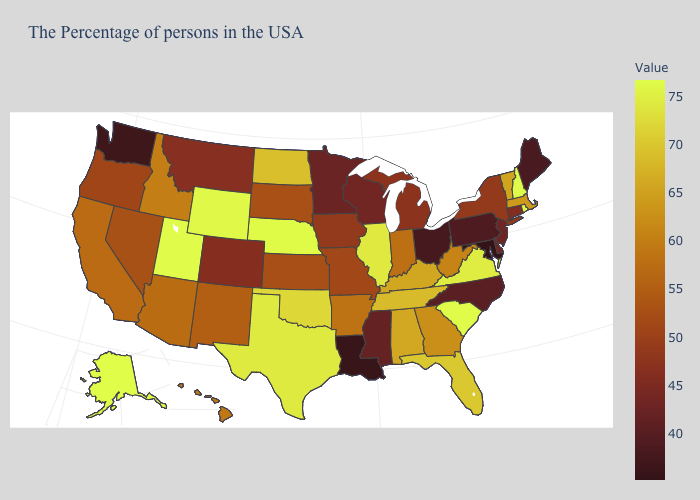Which states have the lowest value in the West?
Keep it brief. Washington. Does Iowa have the lowest value in the USA?
Answer briefly. No. Does Alaska have the highest value in the USA?
Keep it brief. Yes. Does Connecticut have the lowest value in the Northeast?
Be succinct. No. 